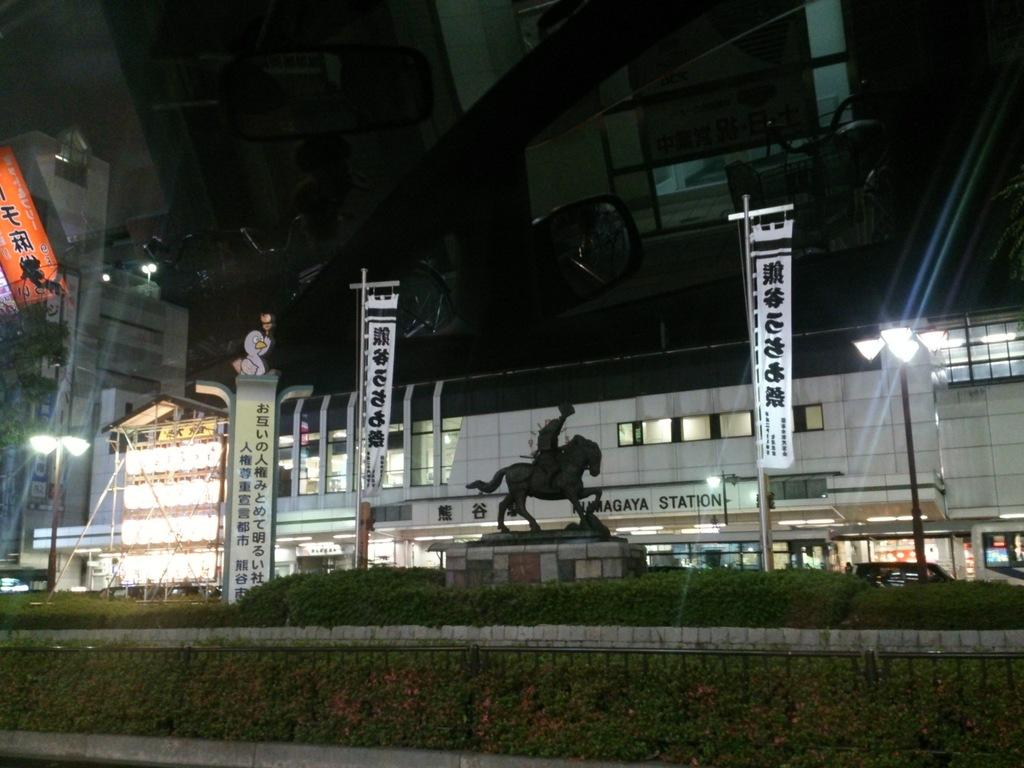What type of vegetation is present in the image? There is grass and plants in the image. What type of structures can be seen in the image? There are buildings in the image. What type of lighting is present in the image? There are lights in the image. What type of support structures are present in the image? There are poles in the image. What can be seen in the background of the image? The sky is visible in the background of the image. Can you see any bananas growing on the plants in the image? There are no bananas visible in the image; the plants are not identified as banana plants. Is there any waste or litter visible in the image? There is no waste or litter visible in the image. 